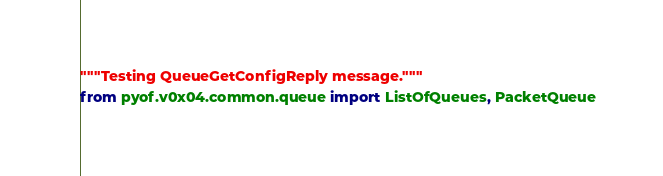Convert code to text. <code><loc_0><loc_0><loc_500><loc_500><_Python_>"""Testing QueueGetConfigReply message."""
from pyof.v0x04.common.queue import ListOfQueues, PacketQueue</code> 